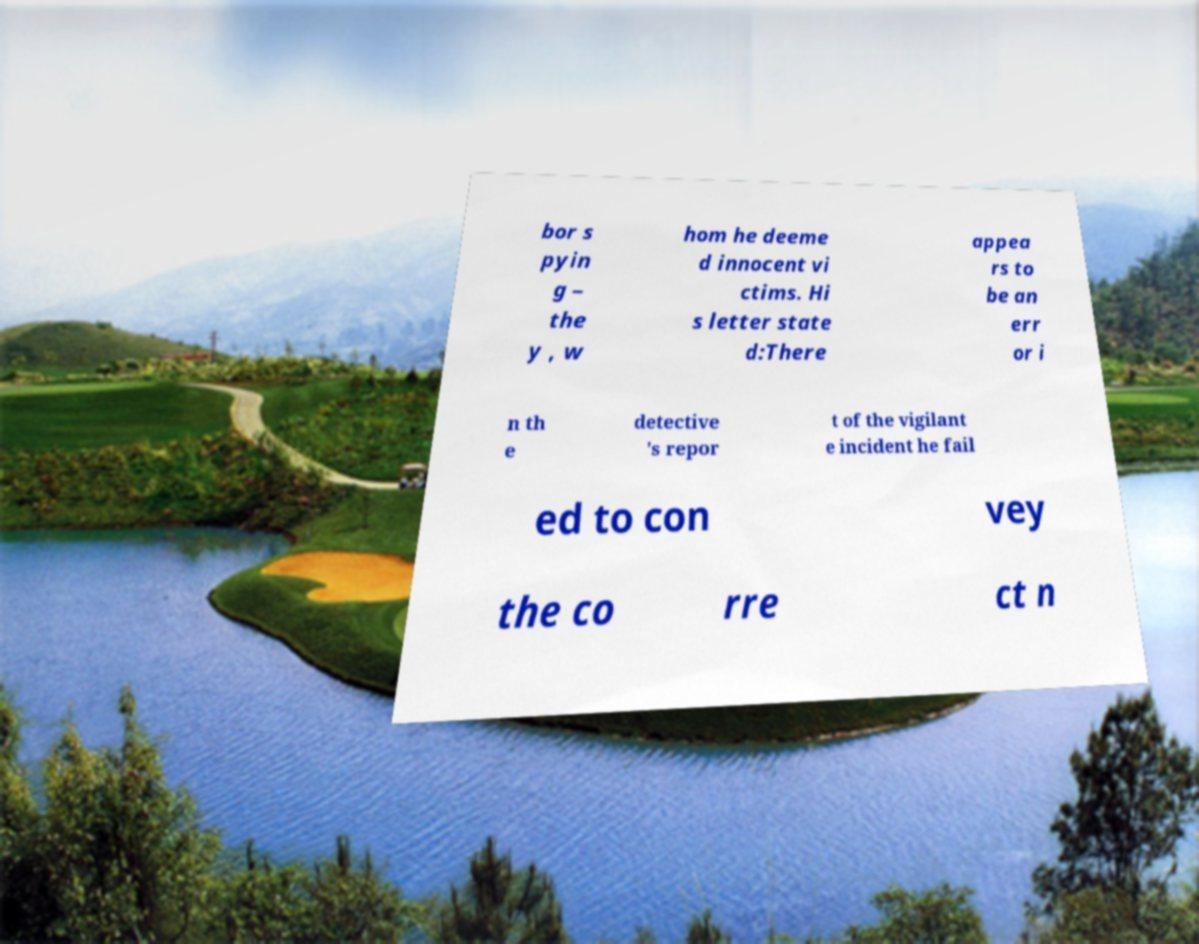I need the written content from this picture converted into text. Can you do that? bor s pyin g – the y , w hom he deeme d innocent vi ctims. Hi s letter state d:There appea rs to be an err or i n th e detective 's repor t of the vigilant e incident he fail ed to con vey the co rre ct n 